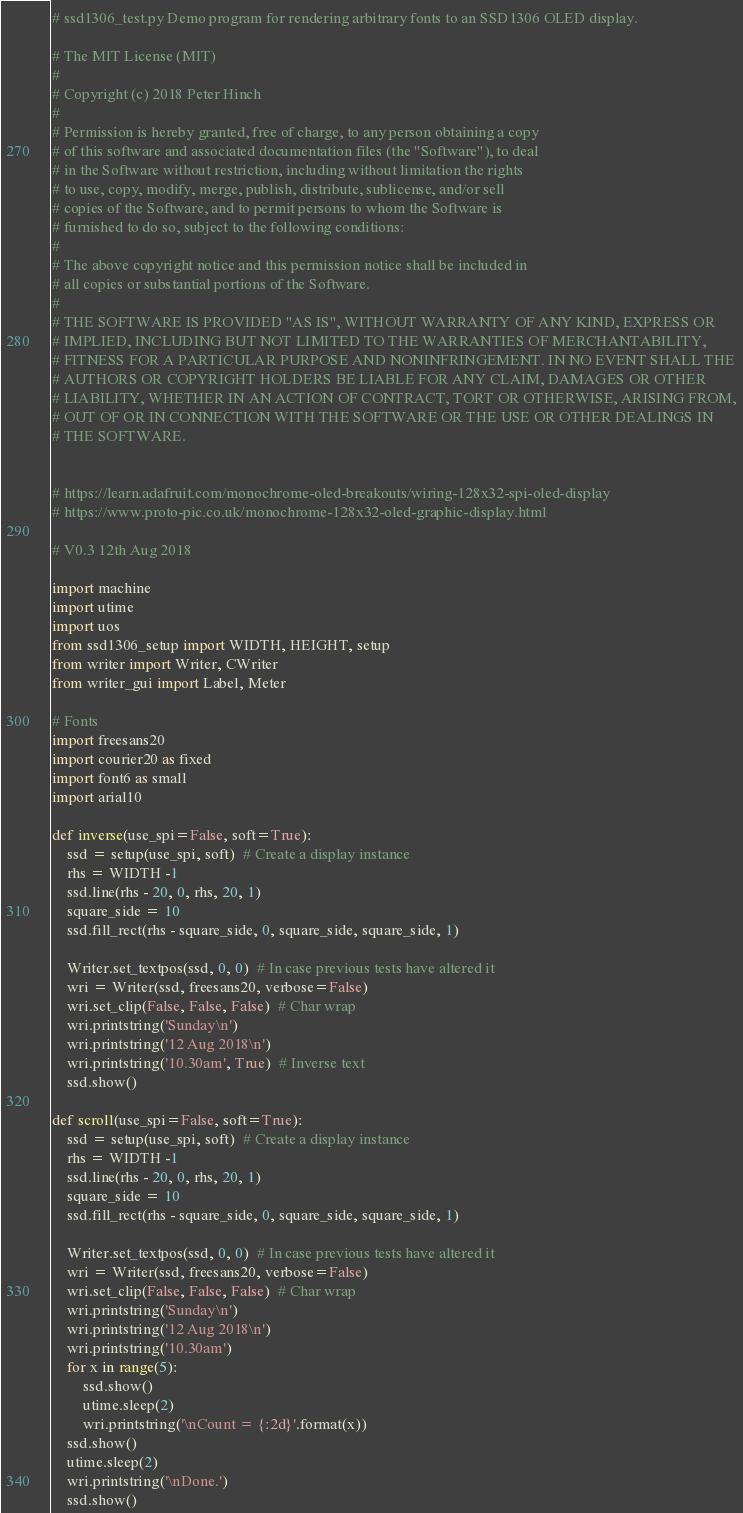Convert code to text. <code><loc_0><loc_0><loc_500><loc_500><_Python_># ssd1306_test.py Demo program for rendering arbitrary fonts to an SSD1306 OLED display.

# The MIT License (MIT)
#
# Copyright (c) 2018 Peter Hinch
#
# Permission is hereby granted, free of charge, to any person obtaining a copy
# of this software and associated documentation files (the "Software"), to deal
# in the Software without restriction, including without limitation the rights
# to use, copy, modify, merge, publish, distribute, sublicense, and/or sell
# copies of the Software, and to permit persons to whom the Software is
# furnished to do so, subject to the following conditions:
#
# The above copyright notice and this permission notice shall be included in
# all copies or substantial portions of the Software.
#
# THE SOFTWARE IS PROVIDED "AS IS", WITHOUT WARRANTY OF ANY KIND, EXPRESS OR
# IMPLIED, INCLUDING BUT NOT LIMITED TO THE WARRANTIES OF MERCHANTABILITY,
# FITNESS FOR A PARTICULAR PURPOSE AND NONINFRINGEMENT. IN NO EVENT SHALL THE
# AUTHORS OR COPYRIGHT HOLDERS BE LIABLE FOR ANY CLAIM, DAMAGES OR OTHER
# LIABILITY, WHETHER IN AN ACTION OF CONTRACT, TORT OR OTHERWISE, ARISING FROM,
# OUT OF OR IN CONNECTION WITH THE SOFTWARE OR THE USE OR OTHER DEALINGS IN
# THE SOFTWARE.


# https://learn.adafruit.com/monochrome-oled-breakouts/wiring-128x32-spi-oled-display
# https://www.proto-pic.co.uk/monochrome-128x32-oled-graphic-display.html

# V0.3 12th Aug 2018

import machine
import utime
import uos
from ssd1306_setup import WIDTH, HEIGHT, setup
from writer import Writer, CWriter
from writer_gui import Label, Meter

# Fonts
import freesans20
import courier20 as fixed
import font6 as small
import arial10

def inverse(use_spi=False, soft=True):
    ssd = setup(use_spi, soft)  # Create a display instance
    rhs = WIDTH -1
    ssd.line(rhs - 20, 0, rhs, 20, 1)
    square_side = 10
    ssd.fill_rect(rhs - square_side, 0, square_side, square_side, 1)

    Writer.set_textpos(ssd, 0, 0)  # In case previous tests have altered it
    wri = Writer(ssd, freesans20, verbose=False)
    wri.set_clip(False, False, False)  # Char wrap
    wri.printstring('Sunday\n')
    wri.printstring('12 Aug 2018\n')
    wri.printstring('10.30am', True)  # Inverse text
    ssd.show()

def scroll(use_spi=False, soft=True):
    ssd = setup(use_spi, soft)  # Create a display instance
    rhs = WIDTH -1
    ssd.line(rhs - 20, 0, rhs, 20, 1)
    square_side = 10
    ssd.fill_rect(rhs - square_side, 0, square_side, square_side, 1)

    Writer.set_textpos(ssd, 0, 0)  # In case previous tests have altered it
    wri = Writer(ssd, freesans20, verbose=False)
    wri.set_clip(False, False, False)  # Char wrap
    wri.printstring('Sunday\n')
    wri.printstring('12 Aug 2018\n')
    wri.printstring('10.30am')
    for x in range(5):
        ssd.show()
        utime.sleep(2)
        wri.printstring('\nCount = {:2d}'.format(x))
    ssd.show()
    utime.sleep(2)
    wri.printstring('\nDone.')
    ssd.show()
</code> 